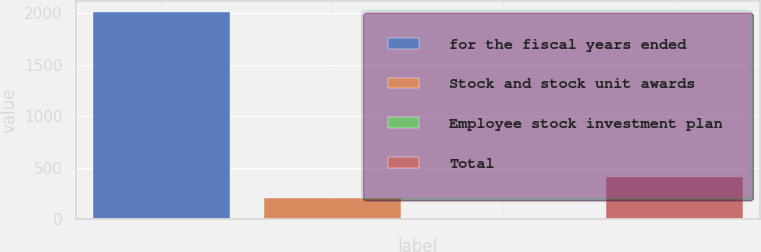Convert chart. <chart><loc_0><loc_0><loc_500><loc_500><bar_chart><fcel>for the fiscal years ended<fcel>Stock and stock unit awards<fcel>Employee stock investment plan<fcel>Total<nl><fcel>2016<fcel>207.18<fcel>6.2<fcel>408.16<nl></chart> 